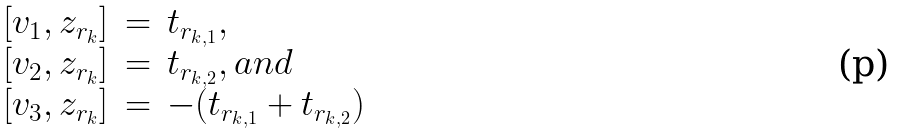Convert formula to latex. <formula><loc_0><loc_0><loc_500><loc_500>\begin{array} { r c l } [ v _ { 1 } , z _ { r _ { k } } ] & = & t _ { r _ { k , 1 } } , \\ \left [ v _ { 2 } , z _ { r _ { k } } \right ] & = & t _ { r _ { k , 2 } } , a n d \\ \left [ v _ { 3 } , z _ { r _ { k } } \right ] & = & - ( t _ { r _ { k , 1 } } + t _ { r _ { k , 2 } } ) \end{array}</formula> 